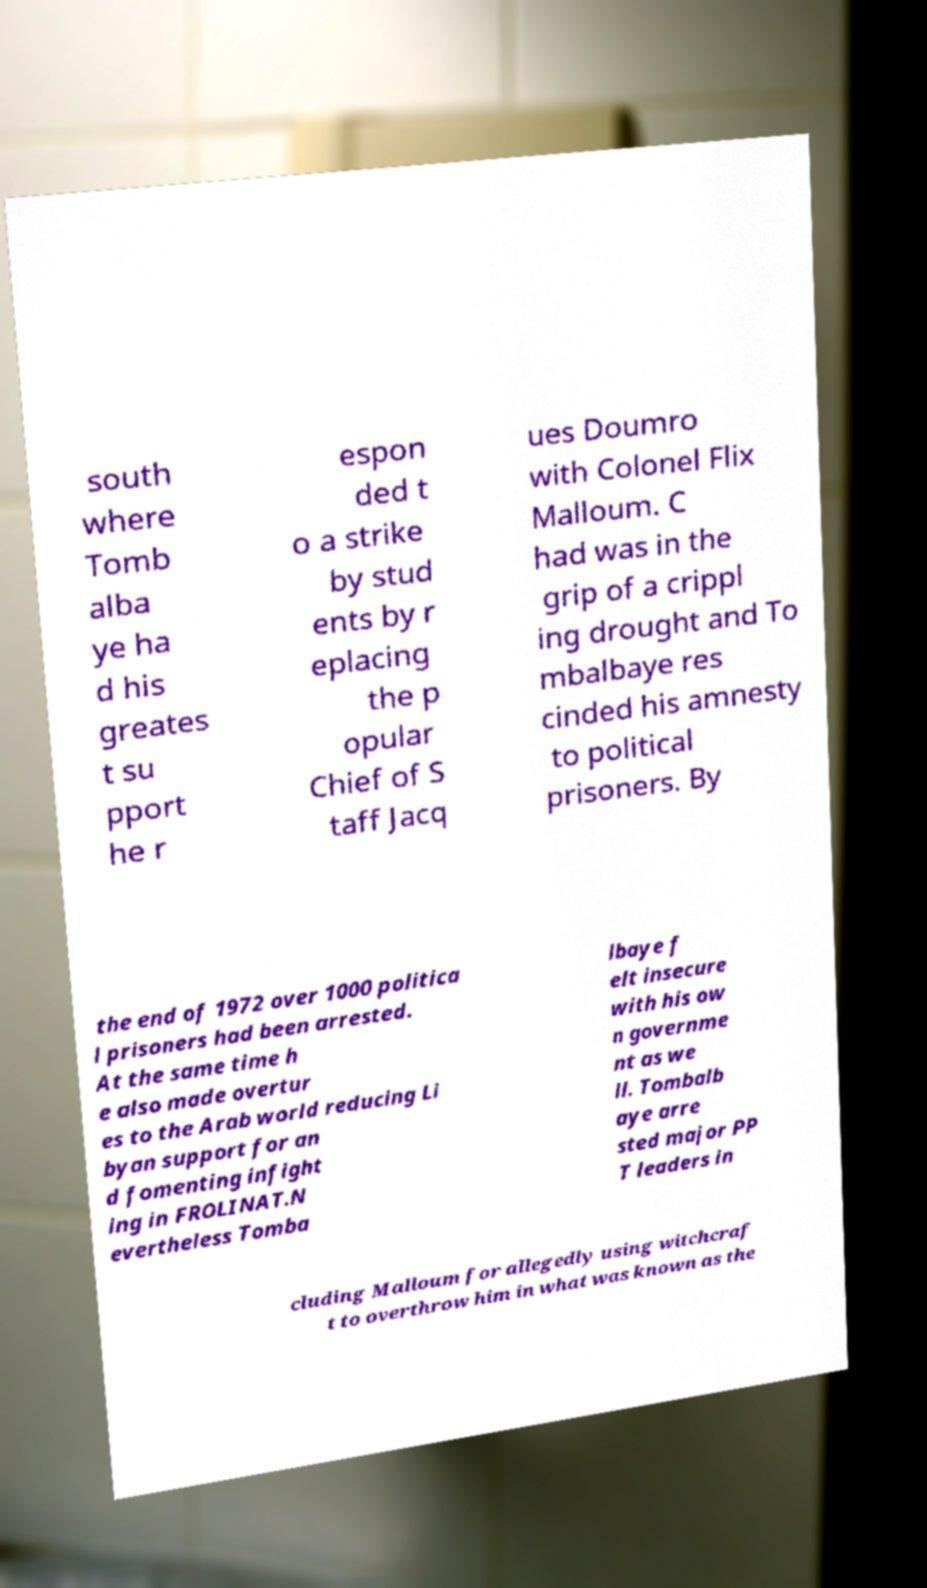There's text embedded in this image that I need extracted. Can you transcribe it verbatim? south where Tomb alba ye ha d his greates t su pport he r espon ded t o a strike by stud ents by r eplacing the p opular Chief of S taff Jacq ues Doumro with Colonel Flix Malloum. C had was in the grip of a crippl ing drought and To mbalbaye res cinded his amnesty to political prisoners. By the end of 1972 over 1000 politica l prisoners had been arrested. At the same time h e also made overtur es to the Arab world reducing Li byan support for an d fomenting infight ing in FROLINAT.N evertheless Tomba lbaye f elt insecure with his ow n governme nt as we ll. Tombalb aye arre sted major PP T leaders in cluding Malloum for allegedly using witchcraf t to overthrow him in what was known as the 